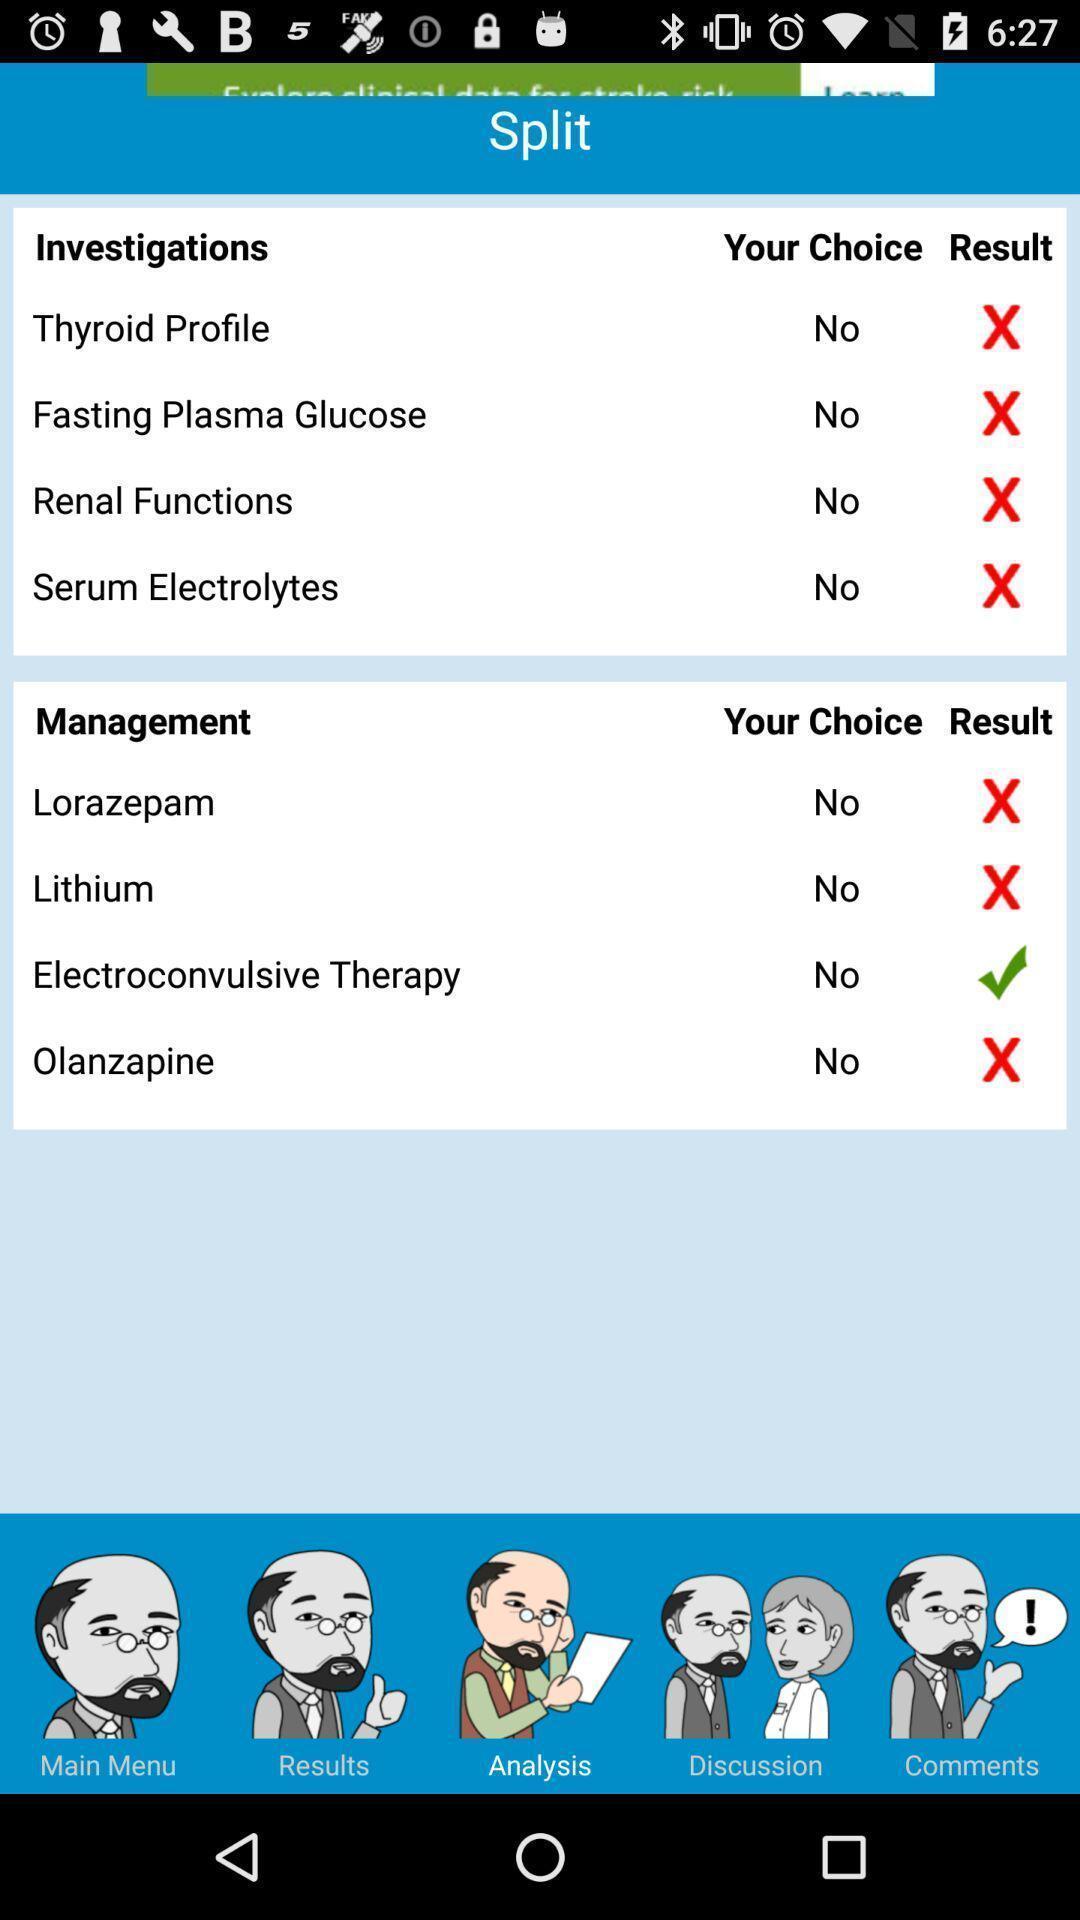Describe the key features of this screenshot. Page displaying analysis of health issues. 